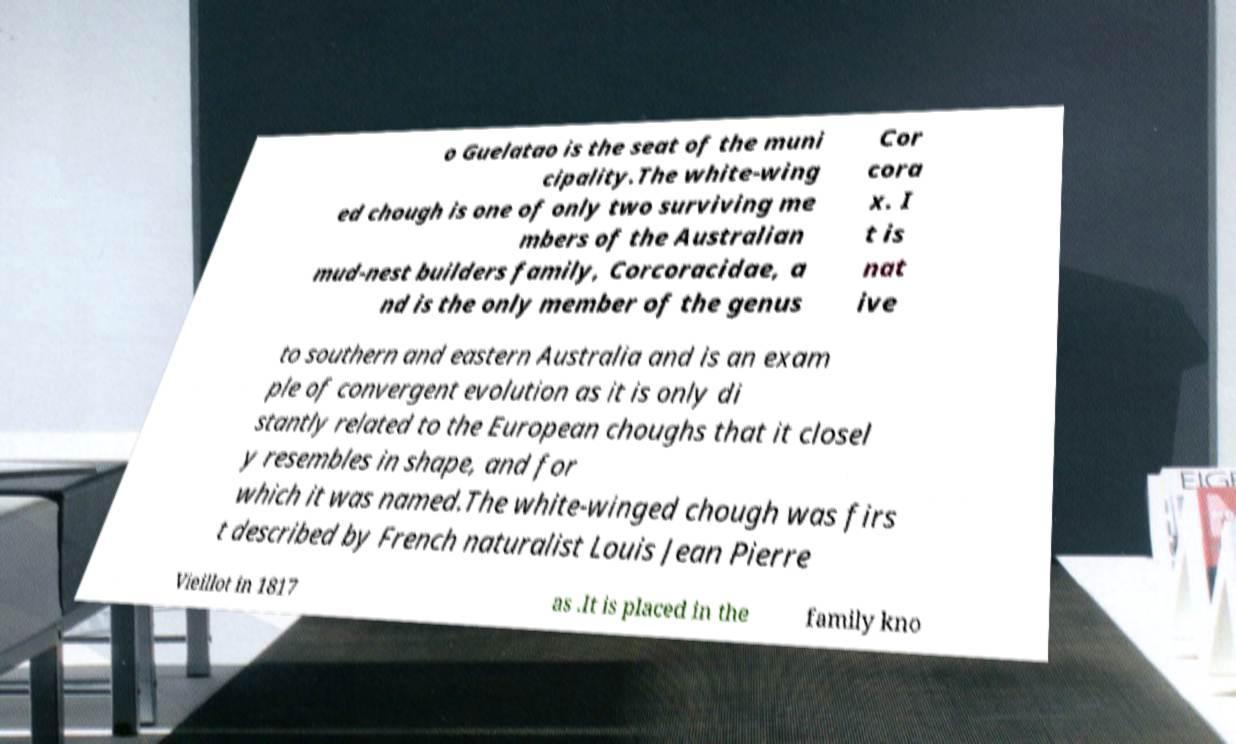I need the written content from this picture converted into text. Can you do that? o Guelatao is the seat of the muni cipality.The white-wing ed chough is one of only two surviving me mbers of the Australian mud-nest builders family, Corcoracidae, a nd is the only member of the genus Cor cora x. I t is nat ive to southern and eastern Australia and is an exam ple of convergent evolution as it is only di stantly related to the European choughs that it closel y resembles in shape, and for which it was named.The white-winged chough was firs t described by French naturalist Louis Jean Pierre Vieillot in 1817 as .It is placed in the family kno 